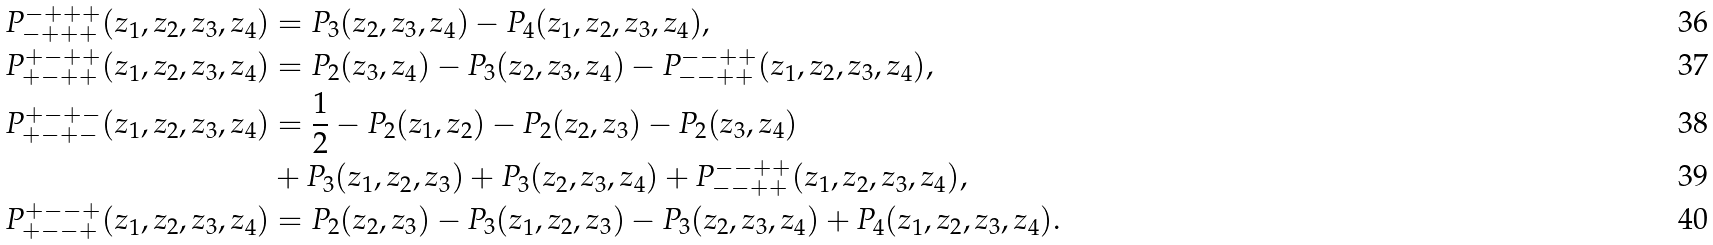<formula> <loc_0><loc_0><loc_500><loc_500>P _ { - + + + } ^ { - + + + } ( z _ { 1 } , z _ { 2 } , z _ { 3 } , z _ { 4 } ) & = P _ { 3 } ( z _ { 2 } , z _ { 3 } , z _ { 4 } ) - P _ { 4 } ( z _ { 1 } , z _ { 2 } , z _ { 3 } , z _ { 4 } ) , \\ P _ { + - + + } ^ { + - + + } ( z _ { 1 } , z _ { 2 } , z _ { 3 } , z _ { 4 } ) & = P _ { 2 } ( z _ { 3 } , z _ { 4 } ) - P _ { 3 } ( z _ { 2 } , z _ { 3 } , z _ { 4 } ) - P _ { - - + + } ^ { - - + + } ( z _ { 1 } , z _ { 2 } , z _ { 3 } , z _ { 4 } ) , \\ P _ { + - + - } ^ { + - + - } ( z _ { 1 } , z _ { 2 } , z _ { 3 } , z _ { 4 } ) & = \frac { 1 } { 2 } - P _ { 2 } ( z _ { 1 } , z _ { 2 } ) - P _ { 2 } ( z _ { 2 } , z _ { 3 } ) - P _ { 2 } ( z _ { 3 } , z _ { 4 } ) \\ & + P _ { 3 } ( z _ { 1 } , z _ { 2 } , z _ { 3 } ) + P _ { 3 } ( z _ { 2 } , z _ { 3 } , z _ { 4 } ) + P _ { - - + + } ^ { - - + + } ( z _ { 1 } , z _ { 2 } , z _ { 3 } , z _ { 4 } ) , \\ P _ { + - - + } ^ { + - - + } ( z _ { 1 } , z _ { 2 } , z _ { 3 } , z _ { 4 } ) & = P _ { 2 } ( z _ { 2 } , z _ { 3 } ) - P _ { 3 } ( z _ { 1 } , z _ { 2 } , z _ { 3 } ) - P _ { 3 } ( z _ { 2 } , z _ { 3 } , z _ { 4 } ) + P _ { 4 } ( z _ { 1 } , z _ { 2 } , z _ { 3 } , z _ { 4 } ) .</formula> 